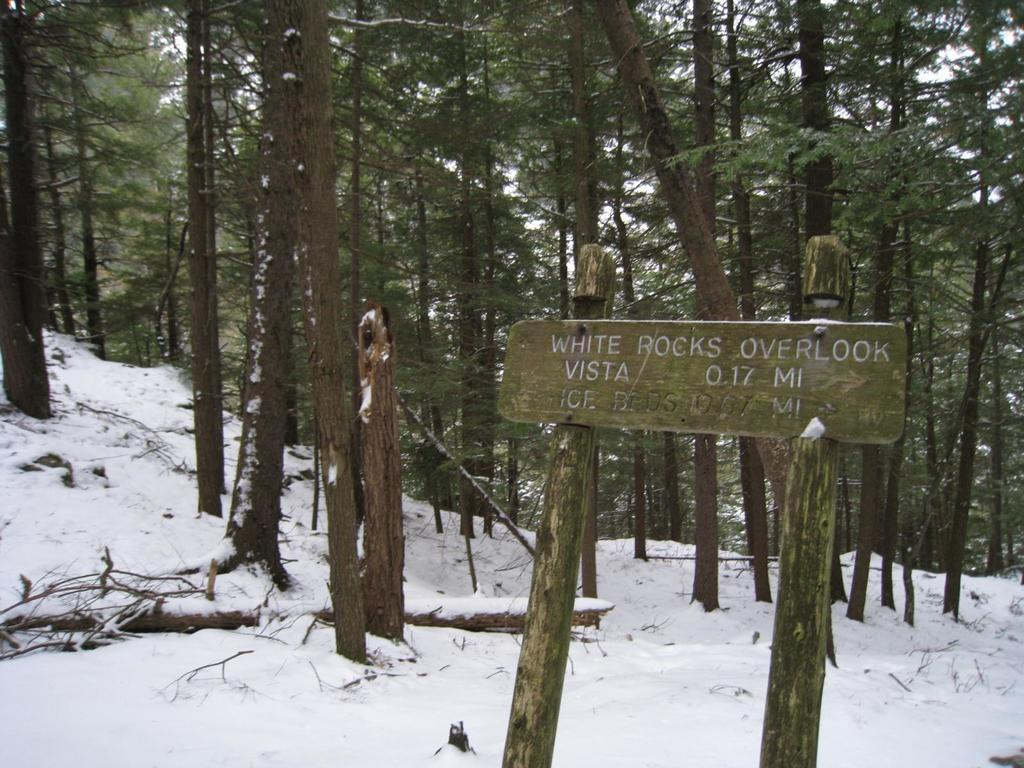What is located at the bottom of the image? There is a sign board at the bottom of the image. What can be seen in the background of the image? There are trees present on the snowy ground in the background. What type of berry can be seen growing on the trees in the image? There are no berries visible on the trees in the image; they are covered in snow. What thrilling activity is taking place in the image? There is no thrilling activity depicted in the image; it simply shows a sign board and trees on snowy ground. 